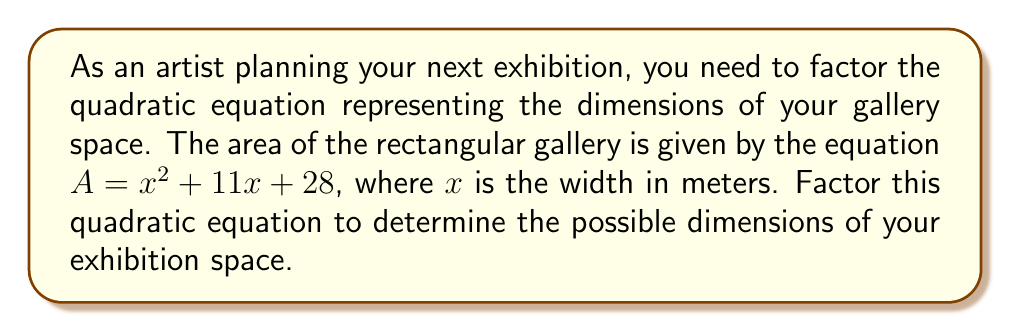Show me your answer to this math problem. To factor this quadratic equation, we'll follow these steps:

1) The quadratic equation is in the form $ax^2 + bx + c$, where:
   $a = 1$
   $b = 11$
   $c = 28$

2) We need to find two numbers that multiply to give $ac = 1 \times 28 = 28$ and add up to $b = 11$.

3) The factors of 28 are: 1, 2, 4, 7, 14, 28.

4) By inspection, we can see that 4 and 7 multiply to give 28 and add up to 11.

5) We can rewrite the middle term using these numbers:
   $x^2 + 11x + 28 = x^2 + 4x + 7x + 28$

6) Now we can factor by grouping:
   $(x^2 + 4x) + (7x + 28)$
   $x(x + 4) + 7(x + 4)$
   $(x + 7)(x + 4)$

Therefore, the factored form of the quadratic equation is $(x + 7)(x + 4)$.

This means that the possible dimensions of your exhibition space are:
Width: $x$ meters
Length: $(x + 7)$ meters or $(x + 4)$ meters
Answer: $(x + 7)(x + 4)$ 